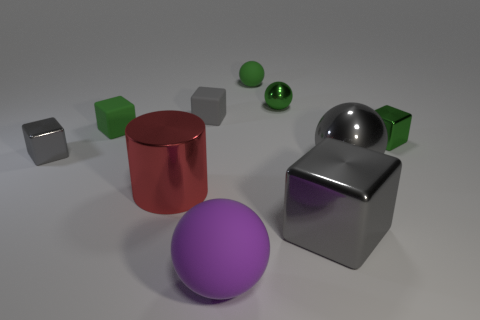Subtract all yellow cylinders. How many gray cubes are left? 3 Subtract all red cubes. Subtract all green balls. How many cubes are left? 5 Subtract all cylinders. How many objects are left? 9 Add 5 purple spheres. How many purple spheres exist? 6 Subtract 2 green balls. How many objects are left? 8 Subtract all big purple objects. Subtract all small balls. How many objects are left? 7 Add 4 shiny spheres. How many shiny spheres are left? 6 